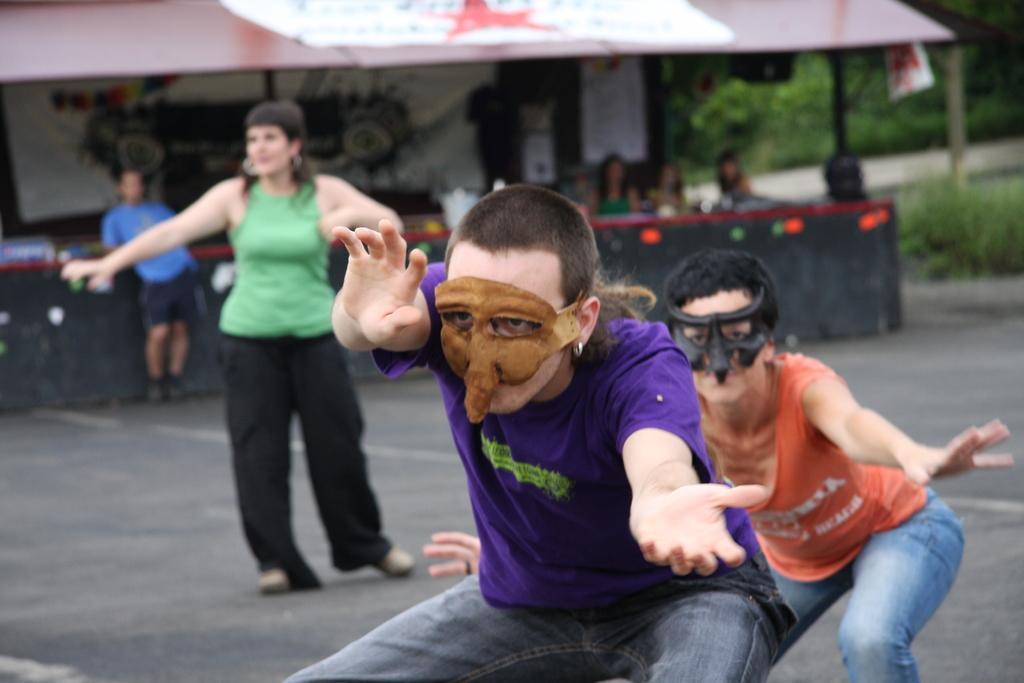Please provide a concise description of this image. This picture is clicked outside and we can see the group of people. In the foreground we can see the two persons wearing t-shirts, face masks and seems to be standing. On the left we can see a woman wearing green color t-shirt and standing on the ground. In the background we can see the tent, tables, group of people, plants and some other objects. 